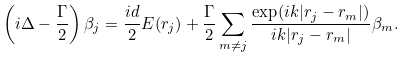<formula> <loc_0><loc_0><loc_500><loc_500>\left ( i \Delta - \frac { \Gamma } { 2 } \right ) \beta _ { j } = \frac { i d } { 2 } E ( r _ { j } ) + \frac { \Gamma } { 2 } \sum _ { m \neq j } \frac { \exp ( i k | r _ { j } - r _ { m } | ) } { i k | r _ { j } - r _ { m } | } \beta _ { m } .</formula> 